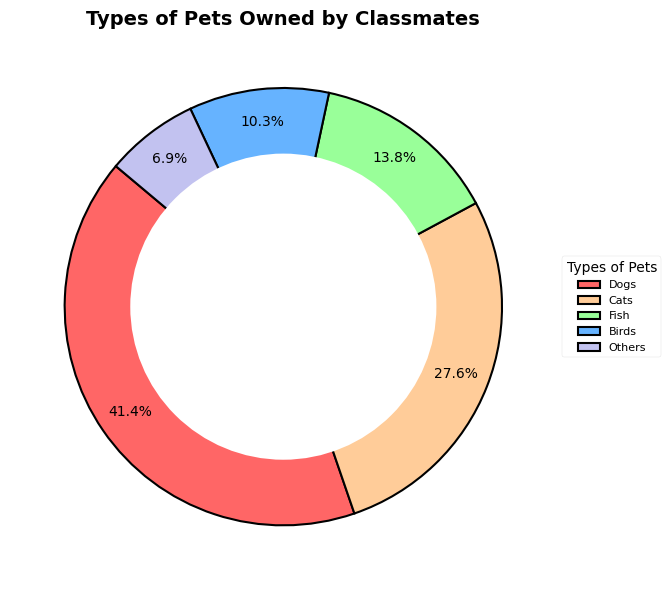What percentage of classmates have cats? Find the slice labeled "Cats" on the pie chart. The percentage value shown on the slice is 28.6%.
Answer: 28.6% Which type of pet is owned by the most classmates? Check the slice that shows the largest percentage. The slice labeled "Dogs" shows the highest percentage of 42.9%.
Answer: Dogs Do more classmates have fish than birds? Compare the two slices labeled "Fish" and "Birds". The "Fish" slice is larger at 14.3% compared to 10.7% for the "Birds" slice.
Answer: Yes How many types of pets are shown in the pie chart? Count the number of different labels around the pie chart. The labels are "Dogs", "Cats", "Fish", "Birds", and "Others". There are 5 labels.
Answer: 5 What is the combined percentage of classmates who own birds and others? Add the percentages for "Birds" (10.7%) and "Others" (7.1%). The total is 10.7% + 7.1% = 17.8%.
Answer: 17.8% What portion of classmates own either dogs or cats? Add the percentages for "Dogs" (42.9%) and "Cats" (28.6%). The sum is 42.9% + 28.6% = 71.5%.
Answer: 71.5% Which slice of the pie chart is red? Identify the color red on the pie chart. The red slice is labeled "Dogs".
Answer: Dogs Is the group that owns cats larger than the group that owns fish and birds combined? Add the percentages for "Fish" (14.3%) and "Birds" (10.7%). The sum is 14.3% + 10.7% = 25%. Compare this to the "Cats" percentage of 28.6%, which is higher.
Answer: Yes Which type of pet is owned by the fewest classmates? Find the smallest slice on the pie chart. The slice labeled "Others" shows the smallest percentage of 7.1%.
Answer: Others 